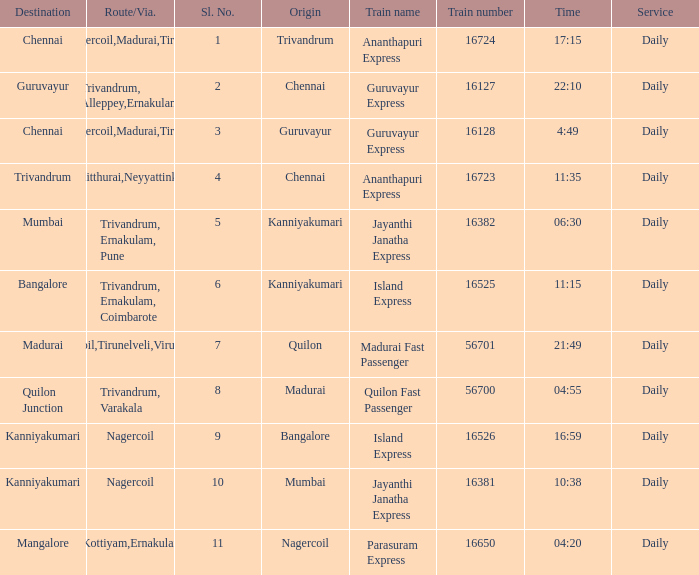Could you parse the entire table as a dict? {'header': ['Destination', 'Route/Via.', 'Sl. No.', 'Origin', 'Train name', 'Train number', 'Time', 'Service'], 'rows': [['Chennai', 'Nagercoil,Madurai,Tiruchi', '1', 'Trivandrum', 'Ananthapuri Express', '16724', '17:15', 'Daily'], ['Guruvayur', 'Trivandrum, Alleppey,Ernakulam', '2', 'Chennai', 'Guruvayur Express', '16127', '22:10', 'Daily'], ['Chennai', 'Nagercoil,Madurai,Tiruchi', '3', 'Guruvayur', 'Guruvayur Express', '16128', '4:49', 'Daily'], ['Trivandrum', 'Kulitthurai,Neyyattinkara', '4', 'Chennai', 'Ananthapuri Express', '16723', '11:35', 'Daily'], ['Mumbai', 'Trivandrum, Ernakulam, Pune', '5', 'Kanniyakumari', 'Jayanthi Janatha Express', '16382', '06:30', 'Daily'], ['Bangalore', 'Trivandrum, Ernakulam, Coimbarote', '6', 'Kanniyakumari', 'Island Express', '16525', '11:15', 'Daily'], ['Madurai', 'Nagercoil,Tirunelveli,Virudunagar', '7', 'Quilon', 'Madurai Fast Passenger', '56701', '21:49', 'Daily'], ['Quilon Junction', 'Trivandrum, Varakala', '8', 'Madurai', 'Quilon Fast Passenger', '56700', '04:55', 'Daily'], ['Kanniyakumari', 'Nagercoil', '9', 'Bangalore', 'Island Express', '16526', '16:59', 'Daily'], ['Kanniyakumari', 'Nagercoil', '10', 'Mumbai', 'Jayanthi Janatha Express', '16381', '10:38', 'Daily'], ['Mangalore', 'Trivandrum,Kottiyam,Ernakulam,Kozhikode', '11', 'Nagercoil', 'Parasuram Express', '16650', '04:20', 'Daily']]} What is the train number when the time is 10:38? 16381.0. 